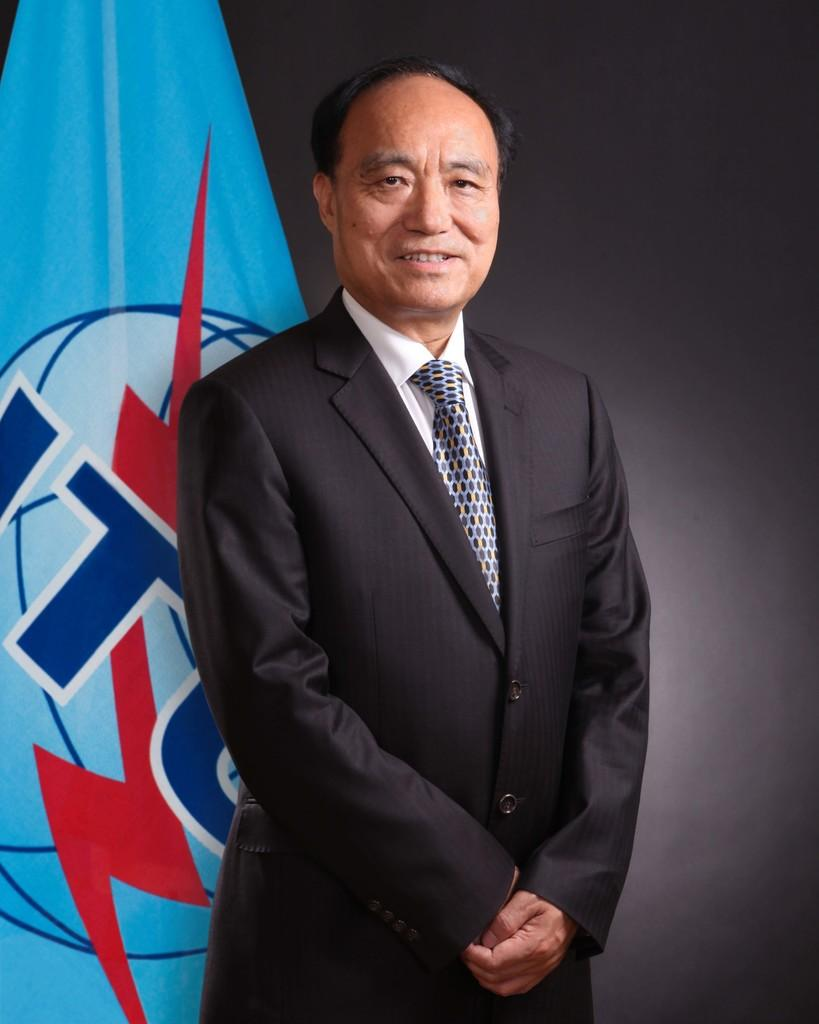Who is present in the image? There is a man in the image. What is the man doing in the image? The man is smiling in the image. What is the man wearing in the image? The man is wearing a black suit in the image. What can be seen in the background of the image? There is a blue color flag in the background of the image. What type of lead is the man holding in the image? There is no lead present in the image; the man is not holding anything. 